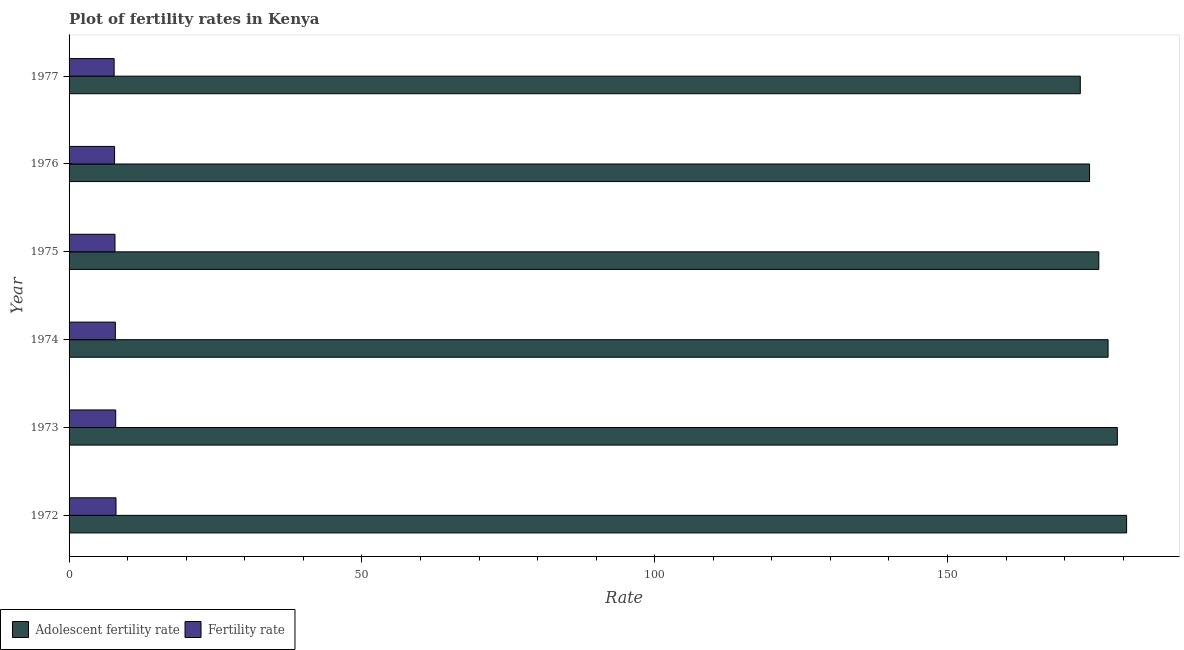Are the number of bars on each tick of the Y-axis equal?
Your answer should be very brief. Yes. What is the label of the 4th group of bars from the top?
Your answer should be very brief. 1974. What is the fertility rate in 1975?
Your response must be concise. 7.84. Across all years, what is the maximum fertility rate?
Give a very brief answer. 8.01. Across all years, what is the minimum adolescent fertility rate?
Keep it short and to the point. 172.66. In which year was the fertility rate minimum?
Provide a short and direct response. 1977. What is the total fertility rate in the graph?
Give a very brief answer. 47.18. What is the difference between the fertility rate in 1973 and that in 1977?
Your response must be concise. 0.27. What is the difference between the adolescent fertility rate in 1977 and the fertility rate in 1972?
Your answer should be very brief. 164.65. What is the average adolescent fertility rate per year?
Your answer should be very brief. 176.62. In the year 1972, what is the difference between the adolescent fertility rate and fertility rate?
Ensure brevity in your answer.  172.56. In how many years, is the adolescent fertility rate greater than 90 ?
Keep it short and to the point. 6. What is the ratio of the fertility rate in 1973 to that in 1975?
Your answer should be compact. 1.02. Is the adolescent fertility rate in 1974 less than that in 1976?
Offer a terse response. No. Is the difference between the adolescent fertility rate in 1972 and 1973 greater than the difference between the fertility rate in 1972 and 1973?
Give a very brief answer. Yes. What is the difference between the highest and the second highest adolescent fertility rate?
Give a very brief answer. 1.58. What is the difference between the highest and the lowest adolescent fertility rate?
Your answer should be compact. 7.91. In how many years, is the fertility rate greater than the average fertility rate taken over all years?
Make the answer very short. 3. What does the 1st bar from the top in 1975 represents?
Your response must be concise. Fertility rate. What does the 1st bar from the bottom in 1973 represents?
Your answer should be compact. Adolescent fertility rate. Are all the bars in the graph horizontal?
Your response must be concise. Yes. What is the difference between two consecutive major ticks on the X-axis?
Give a very brief answer. 50. Does the graph contain any zero values?
Your answer should be compact. No. Does the graph contain grids?
Provide a succinct answer. No. How many legend labels are there?
Provide a short and direct response. 2. How are the legend labels stacked?
Your answer should be very brief. Horizontal. What is the title of the graph?
Ensure brevity in your answer.  Plot of fertility rates in Kenya. What is the label or title of the X-axis?
Ensure brevity in your answer.  Rate. What is the label or title of the Y-axis?
Keep it short and to the point. Year. What is the Rate in Adolescent fertility rate in 1972?
Make the answer very short. 180.57. What is the Rate of Fertility rate in 1972?
Make the answer very short. 8.01. What is the Rate of Adolescent fertility rate in 1973?
Give a very brief answer. 178.99. What is the Rate of Fertility rate in 1973?
Give a very brief answer. 7.96. What is the Rate in Adolescent fertility rate in 1974?
Offer a terse response. 177.41. What is the Rate of Fertility rate in 1974?
Your response must be concise. 7.91. What is the Rate of Adolescent fertility rate in 1975?
Your response must be concise. 175.83. What is the Rate in Fertility rate in 1975?
Your answer should be compact. 7.84. What is the Rate of Adolescent fertility rate in 1976?
Offer a terse response. 174.25. What is the Rate in Fertility rate in 1976?
Provide a succinct answer. 7.77. What is the Rate of Adolescent fertility rate in 1977?
Offer a very short reply. 172.66. What is the Rate of Fertility rate in 1977?
Keep it short and to the point. 7.7. Across all years, what is the maximum Rate in Adolescent fertility rate?
Ensure brevity in your answer.  180.57. Across all years, what is the maximum Rate of Fertility rate?
Make the answer very short. 8.01. Across all years, what is the minimum Rate in Adolescent fertility rate?
Provide a succinct answer. 172.66. Across all years, what is the minimum Rate in Fertility rate?
Offer a very short reply. 7.7. What is the total Rate of Adolescent fertility rate in the graph?
Give a very brief answer. 1059.71. What is the total Rate of Fertility rate in the graph?
Give a very brief answer. 47.18. What is the difference between the Rate of Adolescent fertility rate in 1972 and that in 1973?
Your response must be concise. 1.58. What is the difference between the Rate of Fertility rate in 1972 and that in 1973?
Your answer should be very brief. 0.05. What is the difference between the Rate in Adolescent fertility rate in 1972 and that in 1974?
Your answer should be compact. 3.16. What is the difference between the Rate of Fertility rate in 1972 and that in 1974?
Your response must be concise. 0.11. What is the difference between the Rate in Adolescent fertility rate in 1972 and that in 1975?
Your answer should be compact. 4.75. What is the difference between the Rate in Fertility rate in 1972 and that in 1975?
Make the answer very short. 0.17. What is the difference between the Rate of Adolescent fertility rate in 1972 and that in 1976?
Make the answer very short. 6.33. What is the difference between the Rate of Fertility rate in 1972 and that in 1976?
Your answer should be very brief. 0.24. What is the difference between the Rate of Adolescent fertility rate in 1972 and that in 1977?
Keep it short and to the point. 7.91. What is the difference between the Rate in Fertility rate in 1972 and that in 1977?
Your answer should be very brief. 0.32. What is the difference between the Rate in Adolescent fertility rate in 1973 and that in 1974?
Offer a terse response. 1.58. What is the difference between the Rate of Fertility rate in 1973 and that in 1974?
Your answer should be very brief. 0.06. What is the difference between the Rate in Adolescent fertility rate in 1973 and that in 1975?
Ensure brevity in your answer.  3.16. What is the difference between the Rate of Fertility rate in 1973 and that in 1975?
Your answer should be very brief. 0.12. What is the difference between the Rate in Adolescent fertility rate in 1973 and that in 1976?
Ensure brevity in your answer.  4.75. What is the difference between the Rate of Fertility rate in 1973 and that in 1976?
Give a very brief answer. 0.19. What is the difference between the Rate of Adolescent fertility rate in 1973 and that in 1977?
Keep it short and to the point. 6.33. What is the difference between the Rate in Fertility rate in 1973 and that in 1977?
Offer a very short reply. 0.27. What is the difference between the Rate in Adolescent fertility rate in 1974 and that in 1975?
Ensure brevity in your answer.  1.58. What is the difference between the Rate of Fertility rate in 1974 and that in 1975?
Offer a very short reply. 0.07. What is the difference between the Rate of Adolescent fertility rate in 1974 and that in 1976?
Your answer should be compact. 3.16. What is the difference between the Rate in Fertility rate in 1974 and that in 1976?
Give a very brief answer. 0.14. What is the difference between the Rate in Adolescent fertility rate in 1974 and that in 1977?
Your answer should be very brief. 4.75. What is the difference between the Rate of Fertility rate in 1974 and that in 1977?
Give a very brief answer. 0.21. What is the difference between the Rate in Adolescent fertility rate in 1975 and that in 1976?
Give a very brief answer. 1.58. What is the difference between the Rate of Fertility rate in 1975 and that in 1976?
Ensure brevity in your answer.  0.07. What is the difference between the Rate of Adolescent fertility rate in 1975 and that in 1977?
Make the answer very short. 3.16. What is the difference between the Rate of Fertility rate in 1975 and that in 1977?
Your answer should be compact. 0.14. What is the difference between the Rate in Adolescent fertility rate in 1976 and that in 1977?
Your answer should be compact. 1.58. What is the difference between the Rate in Fertility rate in 1976 and that in 1977?
Provide a succinct answer. 0.07. What is the difference between the Rate in Adolescent fertility rate in 1972 and the Rate in Fertility rate in 1973?
Your answer should be compact. 172.61. What is the difference between the Rate of Adolescent fertility rate in 1972 and the Rate of Fertility rate in 1974?
Offer a terse response. 172.67. What is the difference between the Rate of Adolescent fertility rate in 1972 and the Rate of Fertility rate in 1975?
Offer a terse response. 172.73. What is the difference between the Rate in Adolescent fertility rate in 1972 and the Rate in Fertility rate in 1976?
Your response must be concise. 172.81. What is the difference between the Rate of Adolescent fertility rate in 1972 and the Rate of Fertility rate in 1977?
Your answer should be compact. 172.88. What is the difference between the Rate in Adolescent fertility rate in 1973 and the Rate in Fertility rate in 1974?
Make the answer very short. 171.09. What is the difference between the Rate in Adolescent fertility rate in 1973 and the Rate in Fertility rate in 1975?
Provide a succinct answer. 171.15. What is the difference between the Rate of Adolescent fertility rate in 1973 and the Rate of Fertility rate in 1976?
Ensure brevity in your answer.  171.22. What is the difference between the Rate in Adolescent fertility rate in 1973 and the Rate in Fertility rate in 1977?
Your answer should be very brief. 171.3. What is the difference between the Rate in Adolescent fertility rate in 1974 and the Rate in Fertility rate in 1975?
Your response must be concise. 169.57. What is the difference between the Rate in Adolescent fertility rate in 1974 and the Rate in Fertility rate in 1976?
Provide a succinct answer. 169.64. What is the difference between the Rate in Adolescent fertility rate in 1974 and the Rate in Fertility rate in 1977?
Offer a very short reply. 169.72. What is the difference between the Rate in Adolescent fertility rate in 1975 and the Rate in Fertility rate in 1976?
Give a very brief answer. 168.06. What is the difference between the Rate in Adolescent fertility rate in 1975 and the Rate in Fertility rate in 1977?
Offer a terse response. 168.13. What is the difference between the Rate of Adolescent fertility rate in 1976 and the Rate of Fertility rate in 1977?
Keep it short and to the point. 166.55. What is the average Rate in Adolescent fertility rate per year?
Make the answer very short. 176.62. What is the average Rate of Fertility rate per year?
Provide a short and direct response. 7.86. In the year 1972, what is the difference between the Rate in Adolescent fertility rate and Rate in Fertility rate?
Your response must be concise. 172.56. In the year 1973, what is the difference between the Rate of Adolescent fertility rate and Rate of Fertility rate?
Make the answer very short. 171.03. In the year 1974, what is the difference between the Rate in Adolescent fertility rate and Rate in Fertility rate?
Keep it short and to the point. 169.5. In the year 1975, what is the difference between the Rate of Adolescent fertility rate and Rate of Fertility rate?
Your answer should be compact. 167.99. In the year 1976, what is the difference between the Rate of Adolescent fertility rate and Rate of Fertility rate?
Make the answer very short. 166.48. In the year 1977, what is the difference between the Rate of Adolescent fertility rate and Rate of Fertility rate?
Give a very brief answer. 164.97. What is the ratio of the Rate in Adolescent fertility rate in 1972 to that in 1973?
Keep it short and to the point. 1.01. What is the ratio of the Rate of Fertility rate in 1972 to that in 1973?
Offer a terse response. 1.01. What is the ratio of the Rate of Adolescent fertility rate in 1972 to that in 1974?
Your answer should be compact. 1.02. What is the ratio of the Rate of Fertility rate in 1972 to that in 1974?
Your answer should be compact. 1.01. What is the ratio of the Rate in Fertility rate in 1972 to that in 1975?
Make the answer very short. 1.02. What is the ratio of the Rate in Adolescent fertility rate in 1972 to that in 1976?
Your response must be concise. 1.04. What is the ratio of the Rate in Fertility rate in 1972 to that in 1976?
Your answer should be compact. 1.03. What is the ratio of the Rate of Adolescent fertility rate in 1972 to that in 1977?
Your answer should be very brief. 1.05. What is the ratio of the Rate of Fertility rate in 1972 to that in 1977?
Offer a very short reply. 1.04. What is the ratio of the Rate in Adolescent fertility rate in 1973 to that in 1974?
Your answer should be compact. 1.01. What is the ratio of the Rate in Fertility rate in 1973 to that in 1974?
Your answer should be compact. 1.01. What is the ratio of the Rate in Adolescent fertility rate in 1973 to that in 1975?
Provide a short and direct response. 1.02. What is the ratio of the Rate in Fertility rate in 1973 to that in 1975?
Your answer should be compact. 1.02. What is the ratio of the Rate in Adolescent fertility rate in 1973 to that in 1976?
Offer a terse response. 1.03. What is the ratio of the Rate of Fertility rate in 1973 to that in 1976?
Make the answer very short. 1.02. What is the ratio of the Rate of Adolescent fertility rate in 1973 to that in 1977?
Give a very brief answer. 1.04. What is the ratio of the Rate in Fertility rate in 1973 to that in 1977?
Provide a short and direct response. 1.03. What is the ratio of the Rate in Adolescent fertility rate in 1974 to that in 1975?
Your answer should be very brief. 1.01. What is the ratio of the Rate in Fertility rate in 1974 to that in 1975?
Keep it short and to the point. 1.01. What is the ratio of the Rate in Adolescent fertility rate in 1974 to that in 1976?
Make the answer very short. 1.02. What is the ratio of the Rate of Fertility rate in 1974 to that in 1976?
Keep it short and to the point. 1.02. What is the ratio of the Rate in Adolescent fertility rate in 1974 to that in 1977?
Your response must be concise. 1.03. What is the ratio of the Rate of Fertility rate in 1974 to that in 1977?
Ensure brevity in your answer.  1.03. What is the ratio of the Rate of Adolescent fertility rate in 1975 to that in 1976?
Your answer should be very brief. 1.01. What is the ratio of the Rate in Fertility rate in 1975 to that in 1976?
Offer a terse response. 1.01. What is the ratio of the Rate of Adolescent fertility rate in 1975 to that in 1977?
Provide a succinct answer. 1.02. What is the ratio of the Rate of Fertility rate in 1975 to that in 1977?
Keep it short and to the point. 1.02. What is the ratio of the Rate in Adolescent fertility rate in 1976 to that in 1977?
Your answer should be very brief. 1.01. What is the ratio of the Rate in Fertility rate in 1976 to that in 1977?
Make the answer very short. 1.01. What is the difference between the highest and the second highest Rate of Adolescent fertility rate?
Offer a very short reply. 1.58. What is the difference between the highest and the second highest Rate in Fertility rate?
Offer a terse response. 0.05. What is the difference between the highest and the lowest Rate in Adolescent fertility rate?
Make the answer very short. 7.91. What is the difference between the highest and the lowest Rate in Fertility rate?
Make the answer very short. 0.32. 